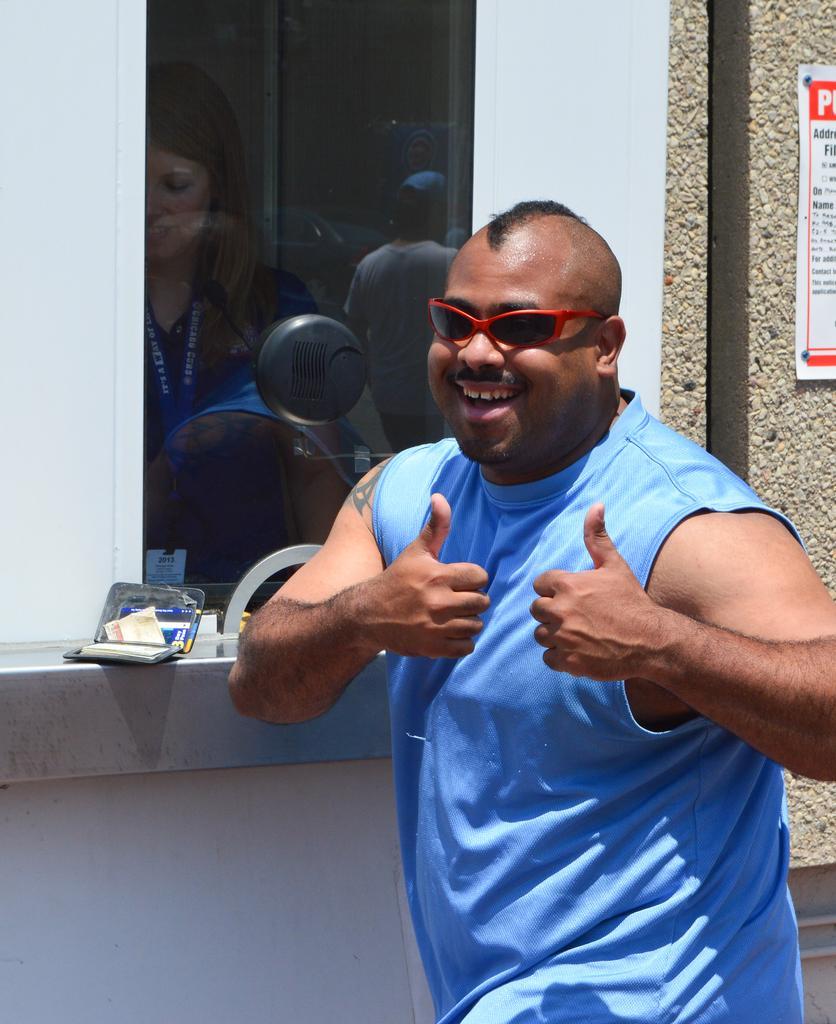Please provide a concise description of this image. In this picture we can see a man, he wore a blue color T-shirt and spectacles, in the mirror reflection we can find few more people, beside to him we can see a poster on the wall. 